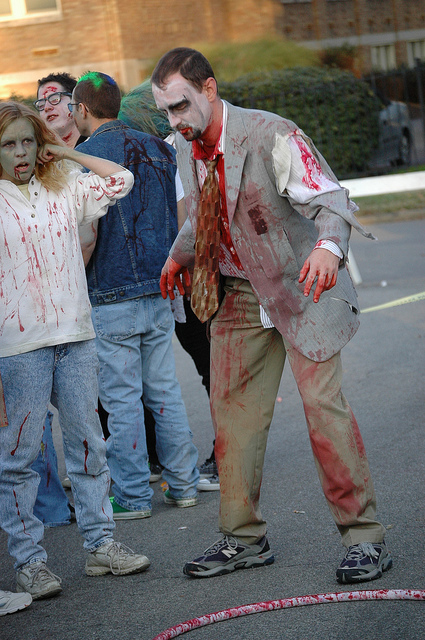Is there anything in the background that gives more context to the event? There is limited context provided by the background as it appears to be a nondescript street scene. However, it's clear that the event is taking place during the day and out in public, which are typical characteristics of a zombie walk or similar outdoor gathering. 